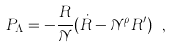Convert formula to latex. <formula><loc_0><loc_0><loc_500><loc_500>P _ { \Lambda } = - \frac { R } { \mathcal { N } } ( \dot { R } - { \mathcal { N } } ^ { \rho } R ^ { \prime } ) \ ,</formula> 